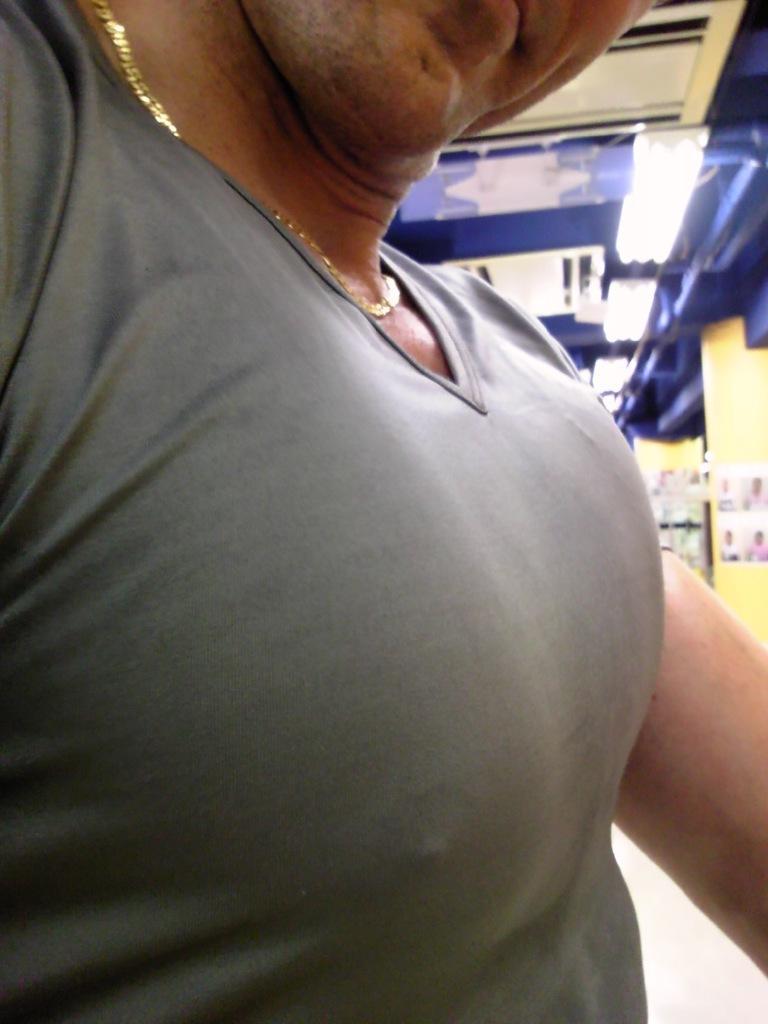Describe this image in one or two sentences. At the top we can see the ceiling and the lights. On the right side of the picture we can see few posts. In this picture we can see a person wearing a t-shirt and we can see a chain around the neck. 